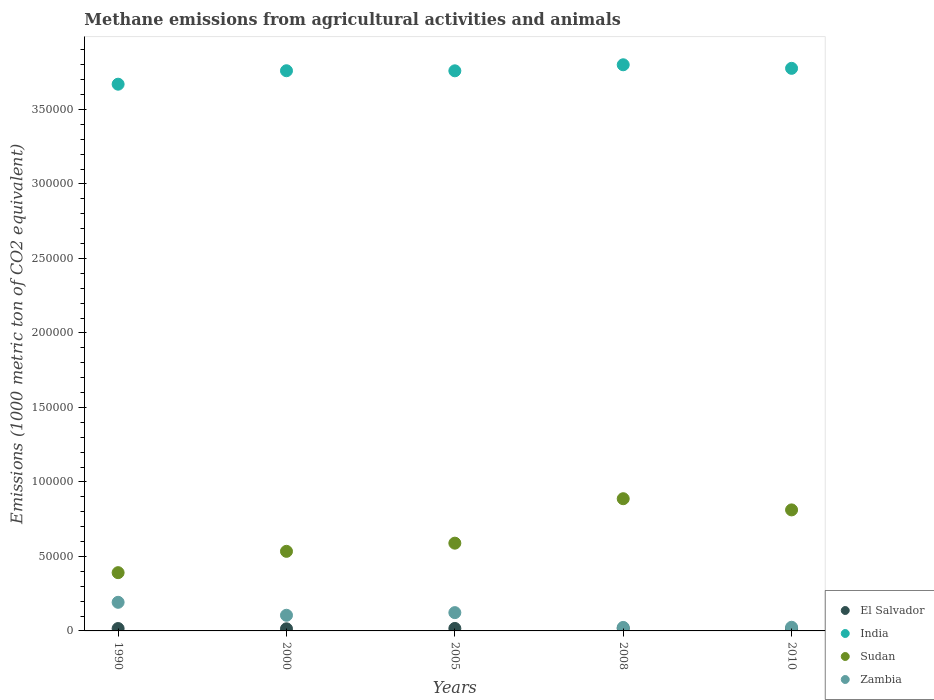How many different coloured dotlines are there?
Your answer should be very brief. 4. Is the number of dotlines equal to the number of legend labels?
Offer a very short reply. Yes. What is the amount of methane emitted in Zambia in 2010?
Offer a terse response. 2457.2. Across all years, what is the maximum amount of methane emitted in El Salvador?
Your answer should be very brief. 1684.6. Across all years, what is the minimum amount of methane emitted in Sudan?
Provide a succinct answer. 3.91e+04. What is the total amount of methane emitted in Zambia in the graph?
Ensure brevity in your answer.  4.68e+04. What is the difference between the amount of methane emitted in Zambia in 2005 and that in 2010?
Your answer should be very brief. 9817.3. What is the difference between the amount of methane emitted in Sudan in 1990 and the amount of methane emitted in El Salvador in 2010?
Provide a short and direct response. 3.75e+04. What is the average amount of methane emitted in Sudan per year?
Give a very brief answer. 6.43e+04. In the year 2008, what is the difference between the amount of methane emitted in Sudan and amount of methane emitted in Zambia?
Give a very brief answer. 8.64e+04. What is the ratio of the amount of methane emitted in Sudan in 1990 to that in 2005?
Your answer should be compact. 0.66. Is the amount of methane emitted in Sudan in 2000 less than that in 2005?
Offer a terse response. Yes. What is the difference between the highest and the second highest amount of methane emitted in El Salvador?
Provide a succinct answer. 22.5. What is the difference between the highest and the lowest amount of methane emitted in Sudan?
Your answer should be very brief. 4.96e+04. Is the sum of the amount of methane emitted in India in 2000 and 2005 greater than the maximum amount of methane emitted in El Salvador across all years?
Your response must be concise. Yes. Is the amount of methane emitted in Zambia strictly greater than the amount of methane emitted in El Salvador over the years?
Your answer should be very brief. Yes. Is the amount of methane emitted in India strictly less than the amount of methane emitted in Zambia over the years?
Provide a short and direct response. No. How many dotlines are there?
Your answer should be very brief. 4. What is the difference between two consecutive major ticks on the Y-axis?
Offer a terse response. 5.00e+04. Are the values on the major ticks of Y-axis written in scientific E-notation?
Provide a succinct answer. No. Does the graph contain any zero values?
Offer a terse response. No. Does the graph contain grids?
Provide a short and direct response. No. How many legend labels are there?
Your answer should be compact. 4. How are the legend labels stacked?
Offer a terse response. Vertical. What is the title of the graph?
Ensure brevity in your answer.  Methane emissions from agricultural activities and animals. What is the label or title of the X-axis?
Your response must be concise. Years. What is the label or title of the Y-axis?
Keep it short and to the point. Emissions (1000 metric ton of CO2 equivalent). What is the Emissions (1000 metric ton of CO2 equivalent) in El Salvador in 1990?
Offer a very short reply. 1599.5. What is the Emissions (1000 metric ton of CO2 equivalent) of India in 1990?
Ensure brevity in your answer.  3.67e+05. What is the Emissions (1000 metric ton of CO2 equivalent) in Sudan in 1990?
Provide a succinct answer. 3.91e+04. What is the Emissions (1000 metric ton of CO2 equivalent) in Zambia in 1990?
Keep it short and to the point. 1.92e+04. What is the Emissions (1000 metric ton of CO2 equivalent) of El Salvador in 2000?
Offer a terse response. 1421.9. What is the Emissions (1000 metric ton of CO2 equivalent) in India in 2000?
Your answer should be very brief. 3.76e+05. What is the Emissions (1000 metric ton of CO2 equivalent) of Sudan in 2000?
Provide a succinct answer. 5.34e+04. What is the Emissions (1000 metric ton of CO2 equivalent) in Zambia in 2000?
Provide a short and direct response. 1.05e+04. What is the Emissions (1000 metric ton of CO2 equivalent) of El Salvador in 2005?
Your answer should be compact. 1662.1. What is the Emissions (1000 metric ton of CO2 equivalent) in India in 2005?
Your response must be concise. 3.76e+05. What is the Emissions (1000 metric ton of CO2 equivalent) in Sudan in 2005?
Provide a succinct answer. 5.89e+04. What is the Emissions (1000 metric ton of CO2 equivalent) of Zambia in 2005?
Your answer should be compact. 1.23e+04. What is the Emissions (1000 metric ton of CO2 equivalent) in El Salvador in 2008?
Provide a short and direct response. 1684.6. What is the Emissions (1000 metric ton of CO2 equivalent) in India in 2008?
Make the answer very short. 3.80e+05. What is the Emissions (1000 metric ton of CO2 equivalent) in Sudan in 2008?
Your answer should be compact. 8.87e+04. What is the Emissions (1000 metric ton of CO2 equivalent) in Zambia in 2008?
Your response must be concise. 2342.5. What is the Emissions (1000 metric ton of CO2 equivalent) in El Salvador in 2010?
Offer a terse response. 1602. What is the Emissions (1000 metric ton of CO2 equivalent) of India in 2010?
Ensure brevity in your answer.  3.78e+05. What is the Emissions (1000 metric ton of CO2 equivalent) of Sudan in 2010?
Make the answer very short. 8.12e+04. What is the Emissions (1000 metric ton of CO2 equivalent) of Zambia in 2010?
Make the answer very short. 2457.2. Across all years, what is the maximum Emissions (1000 metric ton of CO2 equivalent) of El Salvador?
Offer a very short reply. 1684.6. Across all years, what is the maximum Emissions (1000 metric ton of CO2 equivalent) in India?
Offer a terse response. 3.80e+05. Across all years, what is the maximum Emissions (1000 metric ton of CO2 equivalent) of Sudan?
Offer a very short reply. 8.87e+04. Across all years, what is the maximum Emissions (1000 metric ton of CO2 equivalent) of Zambia?
Offer a very short reply. 1.92e+04. Across all years, what is the minimum Emissions (1000 metric ton of CO2 equivalent) of El Salvador?
Give a very brief answer. 1421.9. Across all years, what is the minimum Emissions (1000 metric ton of CO2 equivalent) of India?
Give a very brief answer. 3.67e+05. Across all years, what is the minimum Emissions (1000 metric ton of CO2 equivalent) of Sudan?
Keep it short and to the point. 3.91e+04. Across all years, what is the minimum Emissions (1000 metric ton of CO2 equivalent) in Zambia?
Provide a succinct answer. 2342.5. What is the total Emissions (1000 metric ton of CO2 equivalent) in El Salvador in the graph?
Provide a succinct answer. 7970.1. What is the total Emissions (1000 metric ton of CO2 equivalent) in India in the graph?
Your response must be concise. 1.88e+06. What is the total Emissions (1000 metric ton of CO2 equivalent) in Sudan in the graph?
Your response must be concise. 3.21e+05. What is the total Emissions (1000 metric ton of CO2 equivalent) of Zambia in the graph?
Make the answer very short. 4.68e+04. What is the difference between the Emissions (1000 metric ton of CO2 equivalent) in El Salvador in 1990 and that in 2000?
Ensure brevity in your answer.  177.6. What is the difference between the Emissions (1000 metric ton of CO2 equivalent) in India in 1990 and that in 2000?
Provide a short and direct response. -9029.4. What is the difference between the Emissions (1000 metric ton of CO2 equivalent) of Sudan in 1990 and that in 2000?
Your answer should be very brief. -1.43e+04. What is the difference between the Emissions (1000 metric ton of CO2 equivalent) in Zambia in 1990 and that in 2000?
Provide a short and direct response. 8698.2. What is the difference between the Emissions (1000 metric ton of CO2 equivalent) in El Salvador in 1990 and that in 2005?
Provide a short and direct response. -62.6. What is the difference between the Emissions (1000 metric ton of CO2 equivalent) in India in 1990 and that in 2005?
Your response must be concise. -8983.7. What is the difference between the Emissions (1000 metric ton of CO2 equivalent) in Sudan in 1990 and that in 2005?
Make the answer very short. -1.98e+04. What is the difference between the Emissions (1000 metric ton of CO2 equivalent) of Zambia in 1990 and that in 2005?
Your answer should be compact. 6932.6. What is the difference between the Emissions (1000 metric ton of CO2 equivalent) in El Salvador in 1990 and that in 2008?
Offer a terse response. -85.1. What is the difference between the Emissions (1000 metric ton of CO2 equivalent) of India in 1990 and that in 2008?
Give a very brief answer. -1.30e+04. What is the difference between the Emissions (1000 metric ton of CO2 equivalent) of Sudan in 1990 and that in 2008?
Provide a short and direct response. -4.96e+04. What is the difference between the Emissions (1000 metric ton of CO2 equivalent) of Zambia in 1990 and that in 2008?
Provide a succinct answer. 1.69e+04. What is the difference between the Emissions (1000 metric ton of CO2 equivalent) in El Salvador in 1990 and that in 2010?
Provide a short and direct response. -2.5. What is the difference between the Emissions (1000 metric ton of CO2 equivalent) in India in 1990 and that in 2010?
Your answer should be compact. -1.06e+04. What is the difference between the Emissions (1000 metric ton of CO2 equivalent) in Sudan in 1990 and that in 2010?
Make the answer very short. -4.21e+04. What is the difference between the Emissions (1000 metric ton of CO2 equivalent) of Zambia in 1990 and that in 2010?
Provide a short and direct response. 1.67e+04. What is the difference between the Emissions (1000 metric ton of CO2 equivalent) of El Salvador in 2000 and that in 2005?
Make the answer very short. -240.2. What is the difference between the Emissions (1000 metric ton of CO2 equivalent) of India in 2000 and that in 2005?
Your answer should be compact. 45.7. What is the difference between the Emissions (1000 metric ton of CO2 equivalent) of Sudan in 2000 and that in 2005?
Your response must be concise. -5487.9. What is the difference between the Emissions (1000 metric ton of CO2 equivalent) in Zambia in 2000 and that in 2005?
Your answer should be very brief. -1765.6. What is the difference between the Emissions (1000 metric ton of CO2 equivalent) of El Salvador in 2000 and that in 2008?
Your answer should be compact. -262.7. What is the difference between the Emissions (1000 metric ton of CO2 equivalent) of India in 2000 and that in 2008?
Your response must be concise. -4005.8. What is the difference between the Emissions (1000 metric ton of CO2 equivalent) of Sudan in 2000 and that in 2008?
Offer a terse response. -3.53e+04. What is the difference between the Emissions (1000 metric ton of CO2 equivalent) in Zambia in 2000 and that in 2008?
Provide a short and direct response. 8166.4. What is the difference between the Emissions (1000 metric ton of CO2 equivalent) in El Salvador in 2000 and that in 2010?
Provide a succinct answer. -180.1. What is the difference between the Emissions (1000 metric ton of CO2 equivalent) in India in 2000 and that in 2010?
Keep it short and to the point. -1614.3. What is the difference between the Emissions (1000 metric ton of CO2 equivalent) of Sudan in 2000 and that in 2010?
Your answer should be compact. -2.78e+04. What is the difference between the Emissions (1000 metric ton of CO2 equivalent) in Zambia in 2000 and that in 2010?
Your answer should be compact. 8051.7. What is the difference between the Emissions (1000 metric ton of CO2 equivalent) in El Salvador in 2005 and that in 2008?
Your response must be concise. -22.5. What is the difference between the Emissions (1000 metric ton of CO2 equivalent) of India in 2005 and that in 2008?
Ensure brevity in your answer.  -4051.5. What is the difference between the Emissions (1000 metric ton of CO2 equivalent) of Sudan in 2005 and that in 2008?
Provide a short and direct response. -2.98e+04. What is the difference between the Emissions (1000 metric ton of CO2 equivalent) of Zambia in 2005 and that in 2008?
Offer a terse response. 9932. What is the difference between the Emissions (1000 metric ton of CO2 equivalent) of El Salvador in 2005 and that in 2010?
Ensure brevity in your answer.  60.1. What is the difference between the Emissions (1000 metric ton of CO2 equivalent) in India in 2005 and that in 2010?
Your answer should be compact. -1660. What is the difference between the Emissions (1000 metric ton of CO2 equivalent) in Sudan in 2005 and that in 2010?
Your answer should be very brief. -2.23e+04. What is the difference between the Emissions (1000 metric ton of CO2 equivalent) of Zambia in 2005 and that in 2010?
Give a very brief answer. 9817.3. What is the difference between the Emissions (1000 metric ton of CO2 equivalent) of El Salvador in 2008 and that in 2010?
Offer a very short reply. 82.6. What is the difference between the Emissions (1000 metric ton of CO2 equivalent) of India in 2008 and that in 2010?
Ensure brevity in your answer.  2391.5. What is the difference between the Emissions (1000 metric ton of CO2 equivalent) of Sudan in 2008 and that in 2010?
Keep it short and to the point. 7508.4. What is the difference between the Emissions (1000 metric ton of CO2 equivalent) of Zambia in 2008 and that in 2010?
Provide a short and direct response. -114.7. What is the difference between the Emissions (1000 metric ton of CO2 equivalent) in El Salvador in 1990 and the Emissions (1000 metric ton of CO2 equivalent) in India in 2000?
Make the answer very short. -3.74e+05. What is the difference between the Emissions (1000 metric ton of CO2 equivalent) in El Salvador in 1990 and the Emissions (1000 metric ton of CO2 equivalent) in Sudan in 2000?
Your answer should be compact. -5.18e+04. What is the difference between the Emissions (1000 metric ton of CO2 equivalent) of El Salvador in 1990 and the Emissions (1000 metric ton of CO2 equivalent) of Zambia in 2000?
Ensure brevity in your answer.  -8909.4. What is the difference between the Emissions (1000 metric ton of CO2 equivalent) in India in 1990 and the Emissions (1000 metric ton of CO2 equivalent) in Sudan in 2000?
Your answer should be very brief. 3.14e+05. What is the difference between the Emissions (1000 metric ton of CO2 equivalent) in India in 1990 and the Emissions (1000 metric ton of CO2 equivalent) in Zambia in 2000?
Your response must be concise. 3.56e+05. What is the difference between the Emissions (1000 metric ton of CO2 equivalent) in Sudan in 1990 and the Emissions (1000 metric ton of CO2 equivalent) in Zambia in 2000?
Your response must be concise. 2.86e+04. What is the difference between the Emissions (1000 metric ton of CO2 equivalent) of El Salvador in 1990 and the Emissions (1000 metric ton of CO2 equivalent) of India in 2005?
Your response must be concise. -3.74e+05. What is the difference between the Emissions (1000 metric ton of CO2 equivalent) of El Salvador in 1990 and the Emissions (1000 metric ton of CO2 equivalent) of Sudan in 2005?
Offer a very short reply. -5.73e+04. What is the difference between the Emissions (1000 metric ton of CO2 equivalent) in El Salvador in 1990 and the Emissions (1000 metric ton of CO2 equivalent) in Zambia in 2005?
Give a very brief answer. -1.07e+04. What is the difference between the Emissions (1000 metric ton of CO2 equivalent) in India in 1990 and the Emissions (1000 metric ton of CO2 equivalent) in Sudan in 2005?
Offer a very short reply. 3.08e+05. What is the difference between the Emissions (1000 metric ton of CO2 equivalent) in India in 1990 and the Emissions (1000 metric ton of CO2 equivalent) in Zambia in 2005?
Your answer should be compact. 3.55e+05. What is the difference between the Emissions (1000 metric ton of CO2 equivalent) in Sudan in 1990 and the Emissions (1000 metric ton of CO2 equivalent) in Zambia in 2005?
Your answer should be very brief. 2.68e+04. What is the difference between the Emissions (1000 metric ton of CO2 equivalent) of El Salvador in 1990 and the Emissions (1000 metric ton of CO2 equivalent) of India in 2008?
Provide a succinct answer. -3.78e+05. What is the difference between the Emissions (1000 metric ton of CO2 equivalent) of El Salvador in 1990 and the Emissions (1000 metric ton of CO2 equivalent) of Sudan in 2008?
Ensure brevity in your answer.  -8.71e+04. What is the difference between the Emissions (1000 metric ton of CO2 equivalent) of El Salvador in 1990 and the Emissions (1000 metric ton of CO2 equivalent) of Zambia in 2008?
Your answer should be very brief. -743. What is the difference between the Emissions (1000 metric ton of CO2 equivalent) of India in 1990 and the Emissions (1000 metric ton of CO2 equivalent) of Sudan in 2008?
Offer a terse response. 2.78e+05. What is the difference between the Emissions (1000 metric ton of CO2 equivalent) in India in 1990 and the Emissions (1000 metric ton of CO2 equivalent) in Zambia in 2008?
Your answer should be very brief. 3.65e+05. What is the difference between the Emissions (1000 metric ton of CO2 equivalent) of Sudan in 1990 and the Emissions (1000 metric ton of CO2 equivalent) of Zambia in 2008?
Your response must be concise. 3.68e+04. What is the difference between the Emissions (1000 metric ton of CO2 equivalent) in El Salvador in 1990 and the Emissions (1000 metric ton of CO2 equivalent) in India in 2010?
Offer a very short reply. -3.76e+05. What is the difference between the Emissions (1000 metric ton of CO2 equivalent) of El Salvador in 1990 and the Emissions (1000 metric ton of CO2 equivalent) of Sudan in 2010?
Your answer should be very brief. -7.96e+04. What is the difference between the Emissions (1000 metric ton of CO2 equivalent) of El Salvador in 1990 and the Emissions (1000 metric ton of CO2 equivalent) of Zambia in 2010?
Offer a very short reply. -857.7. What is the difference between the Emissions (1000 metric ton of CO2 equivalent) of India in 1990 and the Emissions (1000 metric ton of CO2 equivalent) of Sudan in 2010?
Make the answer very short. 2.86e+05. What is the difference between the Emissions (1000 metric ton of CO2 equivalent) in India in 1990 and the Emissions (1000 metric ton of CO2 equivalent) in Zambia in 2010?
Your response must be concise. 3.64e+05. What is the difference between the Emissions (1000 metric ton of CO2 equivalent) in Sudan in 1990 and the Emissions (1000 metric ton of CO2 equivalent) in Zambia in 2010?
Give a very brief answer. 3.66e+04. What is the difference between the Emissions (1000 metric ton of CO2 equivalent) in El Salvador in 2000 and the Emissions (1000 metric ton of CO2 equivalent) in India in 2005?
Provide a short and direct response. -3.75e+05. What is the difference between the Emissions (1000 metric ton of CO2 equivalent) of El Salvador in 2000 and the Emissions (1000 metric ton of CO2 equivalent) of Sudan in 2005?
Offer a very short reply. -5.75e+04. What is the difference between the Emissions (1000 metric ton of CO2 equivalent) of El Salvador in 2000 and the Emissions (1000 metric ton of CO2 equivalent) of Zambia in 2005?
Provide a short and direct response. -1.09e+04. What is the difference between the Emissions (1000 metric ton of CO2 equivalent) in India in 2000 and the Emissions (1000 metric ton of CO2 equivalent) in Sudan in 2005?
Offer a terse response. 3.17e+05. What is the difference between the Emissions (1000 metric ton of CO2 equivalent) of India in 2000 and the Emissions (1000 metric ton of CO2 equivalent) of Zambia in 2005?
Your answer should be compact. 3.64e+05. What is the difference between the Emissions (1000 metric ton of CO2 equivalent) of Sudan in 2000 and the Emissions (1000 metric ton of CO2 equivalent) of Zambia in 2005?
Give a very brief answer. 4.11e+04. What is the difference between the Emissions (1000 metric ton of CO2 equivalent) of El Salvador in 2000 and the Emissions (1000 metric ton of CO2 equivalent) of India in 2008?
Your response must be concise. -3.79e+05. What is the difference between the Emissions (1000 metric ton of CO2 equivalent) in El Salvador in 2000 and the Emissions (1000 metric ton of CO2 equivalent) in Sudan in 2008?
Provide a short and direct response. -8.73e+04. What is the difference between the Emissions (1000 metric ton of CO2 equivalent) in El Salvador in 2000 and the Emissions (1000 metric ton of CO2 equivalent) in Zambia in 2008?
Give a very brief answer. -920.6. What is the difference between the Emissions (1000 metric ton of CO2 equivalent) in India in 2000 and the Emissions (1000 metric ton of CO2 equivalent) in Sudan in 2008?
Give a very brief answer. 2.87e+05. What is the difference between the Emissions (1000 metric ton of CO2 equivalent) of India in 2000 and the Emissions (1000 metric ton of CO2 equivalent) of Zambia in 2008?
Your response must be concise. 3.74e+05. What is the difference between the Emissions (1000 metric ton of CO2 equivalent) of Sudan in 2000 and the Emissions (1000 metric ton of CO2 equivalent) of Zambia in 2008?
Ensure brevity in your answer.  5.11e+04. What is the difference between the Emissions (1000 metric ton of CO2 equivalent) of El Salvador in 2000 and the Emissions (1000 metric ton of CO2 equivalent) of India in 2010?
Offer a very short reply. -3.76e+05. What is the difference between the Emissions (1000 metric ton of CO2 equivalent) of El Salvador in 2000 and the Emissions (1000 metric ton of CO2 equivalent) of Sudan in 2010?
Offer a very short reply. -7.98e+04. What is the difference between the Emissions (1000 metric ton of CO2 equivalent) of El Salvador in 2000 and the Emissions (1000 metric ton of CO2 equivalent) of Zambia in 2010?
Make the answer very short. -1035.3. What is the difference between the Emissions (1000 metric ton of CO2 equivalent) in India in 2000 and the Emissions (1000 metric ton of CO2 equivalent) in Sudan in 2010?
Provide a succinct answer. 2.95e+05. What is the difference between the Emissions (1000 metric ton of CO2 equivalent) of India in 2000 and the Emissions (1000 metric ton of CO2 equivalent) of Zambia in 2010?
Keep it short and to the point. 3.74e+05. What is the difference between the Emissions (1000 metric ton of CO2 equivalent) of Sudan in 2000 and the Emissions (1000 metric ton of CO2 equivalent) of Zambia in 2010?
Provide a succinct answer. 5.10e+04. What is the difference between the Emissions (1000 metric ton of CO2 equivalent) in El Salvador in 2005 and the Emissions (1000 metric ton of CO2 equivalent) in India in 2008?
Ensure brevity in your answer.  -3.78e+05. What is the difference between the Emissions (1000 metric ton of CO2 equivalent) of El Salvador in 2005 and the Emissions (1000 metric ton of CO2 equivalent) of Sudan in 2008?
Your answer should be compact. -8.71e+04. What is the difference between the Emissions (1000 metric ton of CO2 equivalent) in El Salvador in 2005 and the Emissions (1000 metric ton of CO2 equivalent) in Zambia in 2008?
Offer a very short reply. -680.4. What is the difference between the Emissions (1000 metric ton of CO2 equivalent) of India in 2005 and the Emissions (1000 metric ton of CO2 equivalent) of Sudan in 2008?
Your answer should be compact. 2.87e+05. What is the difference between the Emissions (1000 metric ton of CO2 equivalent) of India in 2005 and the Emissions (1000 metric ton of CO2 equivalent) of Zambia in 2008?
Make the answer very short. 3.74e+05. What is the difference between the Emissions (1000 metric ton of CO2 equivalent) in Sudan in 2005 and the Emissions (1000 metric ton of CO2 equivalent) in Zambia in 2008?
Your answer should be very brief. 5.66e+04. What is the difference between the Emissions (1000 metric ton of CO2 equivalent) in El Salvador in 2005 and the Emissions (1000 metric ton of CO2 equivalent) in India in 2010?
Make the answer very short. -3.76e+05. What is the difference between the Emissions (1000 metric ton of CO2 equivalent) of El Salvador in 2005 and the Emissions (1000 metric ton of CO2 equivalent) of Sudan in 2010?
Provide a short and direct response. -7.96e+04. What is the difference between the Emissions (1000 metric ton of CO2 equivalent) in El Salvador in 2005 and the Emissions (1000 metric ton of CO2 equivalent) in Zambia in 2010?
Your response must be concise. -795.1. What is the difference between the Emissions (1000 metric ton of CO2 equivalent) of India in 2005 and the Emissions (1000 metric ton of CO2 equivalent) of Sudan in 2010?
Offer a terse response. 2.95e+05. What is the difference between the Emissions (1000 metric ton of CO2 equivalent) of India in 2005 and the Emissions (1000 metric ton of CO2 equivalent) of Zambia in 2010?
Your response must be concise. 3.73e+05. What is the difference between the Emissions (1000 metric ton of CO2 equivalent) of Sudan in 2005 and the Emissions (1000 metric ton of CO2 equivalent) of Zambia in 2010?
Your answer should be compact. 5.64e+04. What is the difference between the Emissions (1000 metric ton of CO2 equivalent) in El Salvador in 2008 and the Emissions (1000 metric ton of CO2 equivalent) in India in 2010?
Give a very brief answer. -3.76e+05. What is the difference between the Emissions (1000 metric ton of CO2 equivalent) in El Salvador in 2008 and the Emissions (1000 metric ton of CO2 equivalent) in Sudan in 2010?
Offer a very short reply. -7.95e+04. What is the difference between the Emissions (1000 metric ton of CO2 equivalent) of El Salvador in 2008 and the Emissions (1000 metric ton of CO2 equivalent) of Zambia in 2010?
Keep it short and to the point. -772.6. What is the difference between the Emissions (1000 metric ton of CO2 equivalent) of India in 2008 and the Emissions (1000 metric ton of CO2 equivalent) of Sudan in 2010?
Your response must be concise. 2.99e+05. What is the difference between the Emissions (1000 metric ton of CO2 equivalent) in India in 2008 and the Emissions (1000 metric ton of CO2 equivalent) in Zambia in 2010?
Offer a terse response. 3.78e+05. What is the difference between the Emissions (1000 metric ton of CO2 equivalent) in Sudan in 2008 and the Emissions (1000 metric ton of CO2 equivalent) in Zambia in 2010?
Ensure brevity in your answer.  8.63e+04. What is the average Emissions (1000 metric ton of CO2 equivalent) in El Salvador per year?
Keep it short and to the point. 1594.02. What is the average Emissions (1000 metric ton of CO2 equivalent) of India per year?
Provide a short and direct response. 3.75e+05. What is the average Emissions (1000 metric ton of CO2 equivalent) of Sudan per year?
Ensure brevity in your answer.  6.43e+04. What is the average Emissions (1000 metric ton of CO2 equivalent) in Zambia per year?
Ensure brevity in your answer.  9358.04. In the year 1990, what is the difference between the Emissions (1000 metric ton of CO2 equivalent) in El Salvador and Emissions (1000 metric ton of CO2 equivalent) in India?
Offer a very short reply. -3.65e+05. In the year 1990, what is the difference between the Emissions (1000 metric ton of CO2 equivalent) of El Salvador and Emissions (1000 metric ton of CO2 equivalent) of Sudan?
Your answer should be compact. -3.75e+04. In the year 1990, what is the difference between the Emissions (1000 metric ton of CO2 equivalent) in El Salvador and Emissions (1000 metric ton of CO2 equivalent) in Zambia?
Your answer should be compact. -1.76e+04. In the year 1990, what is the difference between the Emissions (1000 metric ton of CO2 equivalent) of India and Emissions (1000 metric ton of CO2 equivalent) of Sudan?
Offer a terse response. 3.28e+05. In the year 1990, what is the difference between the Emissions (1000 metric ton of CO2 equivalent) of India and Emissions (1000 metric ton of CO2 equivalent) of Zambia?
Your answer should be compact. 3.48e+05. In the year 1990, what is the difference between the Emissions (1000 metric ton of CO2 equivalent) in Sudan and Emissions (1000 metric ton of CO2 equivalent) in Zambia?
Offer a very short reply. 1.99e+04. In the year 2000, what is the difference between the Emissions (1000 metric ton of CO2 equivalent) of El Salvador and Emissions (1000 metric ton of CO2 equivalent) of India?
Ensure brevity in your answer.  -3.75e+05. In the year 2000, what is the difference between the Emissions (1000 metric ton of CO2 equivalent) of El Salvador and Emissions (1000 metric ton of CO2 equivalent) of Sudan?
Offer a very short reply. -5.20e+04. In the year 2000, what is the difference between the Emissions (1000 metric ton of CO2 equivalent) of El Salvador and Emissions (1000 metric ton of CO2 equivalent) of Zambia?
Your answer should be compact. -9087. In the year 2000, what is the difference between the Emissions (1000 metric ton of CO2 equivalent) in India and Emissions (1000 metric ton of CO2 equivalent) in Sudan?
Your response must be concise. 3.23e+05. In the year 2000, what is the difference between the Emissions (1000 metric ton of CO2 equivalent) of India and Emissions (1000 metric ton of CO2 equivalent) of Zambia?
Your response must be concise. 3.65e+05. In the year 2000, what is the difference between the Emissions (1000 metric ton of CO2 equivalent) in Sudan and Emissions (1000 metric ton of CO2 equivalent) in Zambia?
Keep it short and to the point. 4.29e+04. In the year 2005, what is the difference between the Emissions (1000 metric ton of CO2 equivalent) in El Salvador and Emissions (1000 metric ton of CO2 equivalent) in India?
Keep it short and to the point. -3.74e+05. In the year 2005, what is the difference between the Emissions (1000 metric ton of CO2 equivalent) of El Salvador and Emissions (1000 metric ton of CO2 equivalent) of Sudan?
Offer a terse response. -5.72e+04. In the year 2005, what is the difference between the Emissions (1000 metric ton of CO2 equivalent) in El Salvador and Emissions (1000 metric ton of CO2 equivalent) in Zambia?
Give a very brief answer. -1.06e+04. In the year 2005, what is the difference between the Emissions (1000 metric ton of CO2 equivalent) of India and Emissions (1000 metric ton of CO2 equivalent) of Sudan?
Your answer should be very brief. 3.17e+05. In the year 2005, what is the difference between the Emissions (1000 metric ton of CO2 equivalent) of India and Emissions (1000 metric ton of CO2 equivalent) of Zambia?
Offer a terse response. 3.64e+05. In the year 2005, what is the difference between the Emissions (1000 metric ton of CO2 equivalent) of Sudan and Emissions (1000 metric ton of CO2 equivalent) of Zambia?
Offer a terse response. 4.66e+04. In the year 2008, what is the difference between the Emissions (1000 metric ton of CO2 equivalent) in El Salvador and Emissions (1000 metric ton of CO2 equivalent) in India?
Offer a terse response. -3.78e+05. In the year 2008, what is the difference between the Emissions (1000 metric ton of CO2 equivalent) of El Salvador and Emissions (1000 metric ton of CO2 equivalent) of Sudan?
Offer a very short reply. -8.71e+04. In the year 2008, what is the difference between the Emissions (1000 metric ton of CO2 equivalent) of El Salvador and Emissions (1000 metric ton of CO2 equivalent) of Zambia?
Your response must be concise. -657.9. In the year 2008, what is the difference between the Emissions (1000 metric ton of CO2 equivalent) of India and Emissions (1000 metric ton of CO2 equivalent) of Sudan?
Provide a short and direct response. 2.91e+05. In the year 2008, what is the difference between the Emissions (1000 metric ton of CO2 equivalent) of India and Emissions (1000 metric ton of CO2 equivalent) of Zambia?
Give a very brief answer. 3.78e+05. In the year 2008, what is the difference between the Emissions (1000 metric ton of CO2 equivalent) of Sudan and Emissions (1000 metric ton of CO2 equivalent) of Zambia?
Your response must be concise. 8.64e+04. In the year 2010, what is the difference between the Emissions (1000 metric ton of CO2 equivalent) of El Salvador and Emissions (1000 metric ton of CO2 equivalent) of India?
Keep it short and to the point. -3.76e+05. In the year 2010, what is the difference between the Emissions (1000 metric ton of CO2 equivalent) in El Salvador and Emissions (1000 metric ton of CO2 equivalent) in Sudan?
Keep it short and to the point. -7.96e+04. In the year 2010, what is the difference between the Emissions (1000 metric ton of CO2 equivalent) in El Salvador and Emissions (1000 metric ton of CO2 equivalent) in Zambia?
Offer a terse response. -855.2. In the year 2010, what is the difference between the Emissions (1000 metric ton of CO2 equivalent) in India and Emissions (1000 metric ton of CO2 equivalent) in Sudan?
Give a very brief answer. 2.96e+05. In the year 2010, what is the difference between the Emissions (1000 metric ton of CO2 equivalent) in India and Emissions (1000 metric ton of CO2 equivalent) in Zambia?
Give a very brief answer. 3.75e+05. In the year 2010, what is the difference between the Emissions (1000 metric ton of CO2 equivalent) of Sudan and Emissions (1000 metric ton of CO2 equivalent) of Zambia?
Keep it short and to the point. 7.88e+04. What is the ratio of the Emissions (1000 metric ton of CO2 equivalent) in El Salvador in 1990 to that in 2000?
Keep it short and to the point. 1.12. What is the ratio of the Emissions (1000 metric ton of CO2 equivalent) of Sudan in 1990 to that in 2000?
Provide a succinct answer. 0.73. What is the ratio of the Emissions (1000 metric ton of CO2 equivalent) in Zambia in 1990 to that in 2000?
Keep it short and to the point. 1.83. What is the ratio of the Emissions (1000 metric ton of CO2 equivalent) of El Salvador in 1990 to that in 2005?
Provide a short and direct response. 0.96. What is the ratio of the Emissions (1000 metric ton of CO2 equivalent) of India in 1990 to that in 2005?
Your answer should be very brief. 0.98. What is the ratio of the Emissions (1000 metric ton of CO2 equivalent) of Sudan in 1990 to that in 2005?
Give a very brief answer. 0.66. What is the ratio of the Emissions (1000 metric ton of CO2 equivalent) of Zambia in 1990 to that in 2005?
Make the answer very short. 1.56. What is the ratio of the Emissions (1000 metric ton of CO2 equivalent) of El Salvador in 1990 to that in 2008?
Ensure brevity in your answer.  0.95. What is the ratio of the Emissions (1000 metric ton of CO2 equivalent) of India in 1990 to that in 2008?
Ensure brevity in your answer.  0.97. What is the ratio of the Emissions (1000 metric ton of CO2 equivalent) in Sudan in 1990 to that in 2008?
Offer a very short reply. 0.44. What is the ratio of the Emissions (1000 metric ton of CO2 equivalent) of Zambia in 1990 to that in 2008?
Your response must be concise. 8.2. What is the ratio of the Emissions (1000 metric ton of CO2 equivalent) of India in 1990 to that in 2010?
Offer a terse response. 0.97. What is the ratio of the Emissions (1000 metric ton of CO2 equivalent) in Sudan in 1990 to that in 2010?
Your response must be concise. 0.48. What is the ratio of the Emissions (1000 metric ton of CO2 equivalent) of Zambia in 1990 to that in 2010?
Your answer should be compact. 7.82. What is the ratio of the Emissions (1000 metric ton of CO2 equivalent) in El Salvador in 2000 to that in 2005?
Offer a very short reply. 0.86. What is the ratio of the Emissions (1000 metric ton of CO2 equivalent) in Sudan in 2000 to that in 2005?
Your response must be concise. 0.91. What is the ratio of the Emissions (1000 metric ton of CO2 equivalent) of Zambia in 2000 to that in 2005?
Provide a short and direct response. 0.86. What is the ratio of the Emissions (1000 metric ton of CO2 equivalent) in El Salvador in 2000 to that in 2008?
Your answer should be very brief. 0.84. What is the ratio of the Emissions (1000 metric ton of CO2 equivalent) in Sudan in 2000 to that in 2008?
Your answer should be compact. 0.6. What is the ratio of the Emissions (1000 metric ton of CO2 equivalent) of Zambia in 2000 to that in 2008?
Your answer should be very brief. 4.49. What is the ratio of the Emissions (1000 metric ton of CO2 equivalent) in El Salvador in 2000 to that in 2010?
Keep it short and to the point. 0.89. What is the ratio of the Emissions (1000 metric ton of CO2 equivalent) of India in 2000 to that in 2010?
Provide a succinct answer. 1. What is the ratio of the Emissions (1000 metric ton of CO2 equivalent) in Sudan in 2000 to that in 2010?
Ensure brevity in your answer.  0.66. What is the ratio of the Emissions (1000 metric ton of CO2 equivalent) in Zambia in 2000 to that in 2010?
Give a very brief answer. 4.28. What is the ratio of the Emissions (1000 metric ton of CO2 equivalent) of El Salvador in 2005 to that in 2008?
Provide a succinct answer. 0.99. What is the ratio of the Emissions (1000 metric ton of CO2 equivalent) in India in 2005 to that in 2008?
Keep it short and to the point. 0.99. What is the ratio of the Emissions (1000 metric ton of CO2 equivalent) of Sudan in 2005 to that in 2008?
Your answer should be very brief. 0.66. What is the ratio of the Emissions (1000 metric ton of CO2 equivalent) in Zambia in 2005 to that in 2008?
Offer a very short reply. 5.24. What is the ratio of the Emissions (1000 metric ton of CO2 equivalent) of El Salvador in 2005 to that in 2010?
Ensure brevity in your answer.  1.04. What is the ratio of the Emissions (1000 metric ton of CO2 equivalent) in India in 2005 to that in 2010?
Offer a very short reply. 1. What is the ratio of the Emissions (1000 metric ton of CO2 equivalent) in Sudan in 2005 to that in 2010?
Your response must be concise. 0.73. What is the ratio of the Emissions (1000 metric ton of CO2 equivalent) of Zambia in 2005 to that in 2010?
Ensure brevity in your answer.  5. What is the ratio of the Emissions (1000 metric ton of CO2 equivalent) of El Salvador in 2008 to that in 2010?
Provide a succinct answer. 1.05. What is the ratio of the Emissions (1000 metric ton of CO2 equivalent) of Sudan in 2008 to that in 2010?
Offer a very short reply. 1.09. What is the ratio of the Emissions (1000 metric ton of CO2 equivalent) of Zambia in 2008 to that in 2010?
Offer a very short reply. 0.95. What is the difference between the highest and the second highest Emissions (1000 metric ton of CO2 equivalent) of El Salvador?
Offer a terse response. 22.5. What is the difference between the highest and the second highest Emissions (1000 metric ton of CO2 equivalent) in India?
Provide a short and direct response. 2391.5. What is the difference between the highest and the second highest Emissions (1000 metric ton of CO2 equivalent) in Sudan?
Ensure brevity in your answer.  7508.4. What is the difference between the highest and the second highest Emissions (1000 metric ton of CO2 equivalent) in Zambia?
Provide a short and direct response. 6932.6. What is the difference between the highest and the lowest Emissions (1000 metric ton of CO2 equivalent) in El Salvador?
Offer a terse response. 262.7. What is the difference between the highest and the lowest Emissions (1000 metric ton of CO2 equivalent) of India?
Provide a short and direct response. 1.30e+04. What is the difference between the highest and the lowest Emissions (1000 metric ton of CO2 equivalent) of Sudan?
Keep it short and to the point. 4.96e+04. What is the difference between the highest and the lowest Emissions (1000 metric ton of CO2 equivalent) of Zambia?
Offer a very short reply. 1.69e+04. 